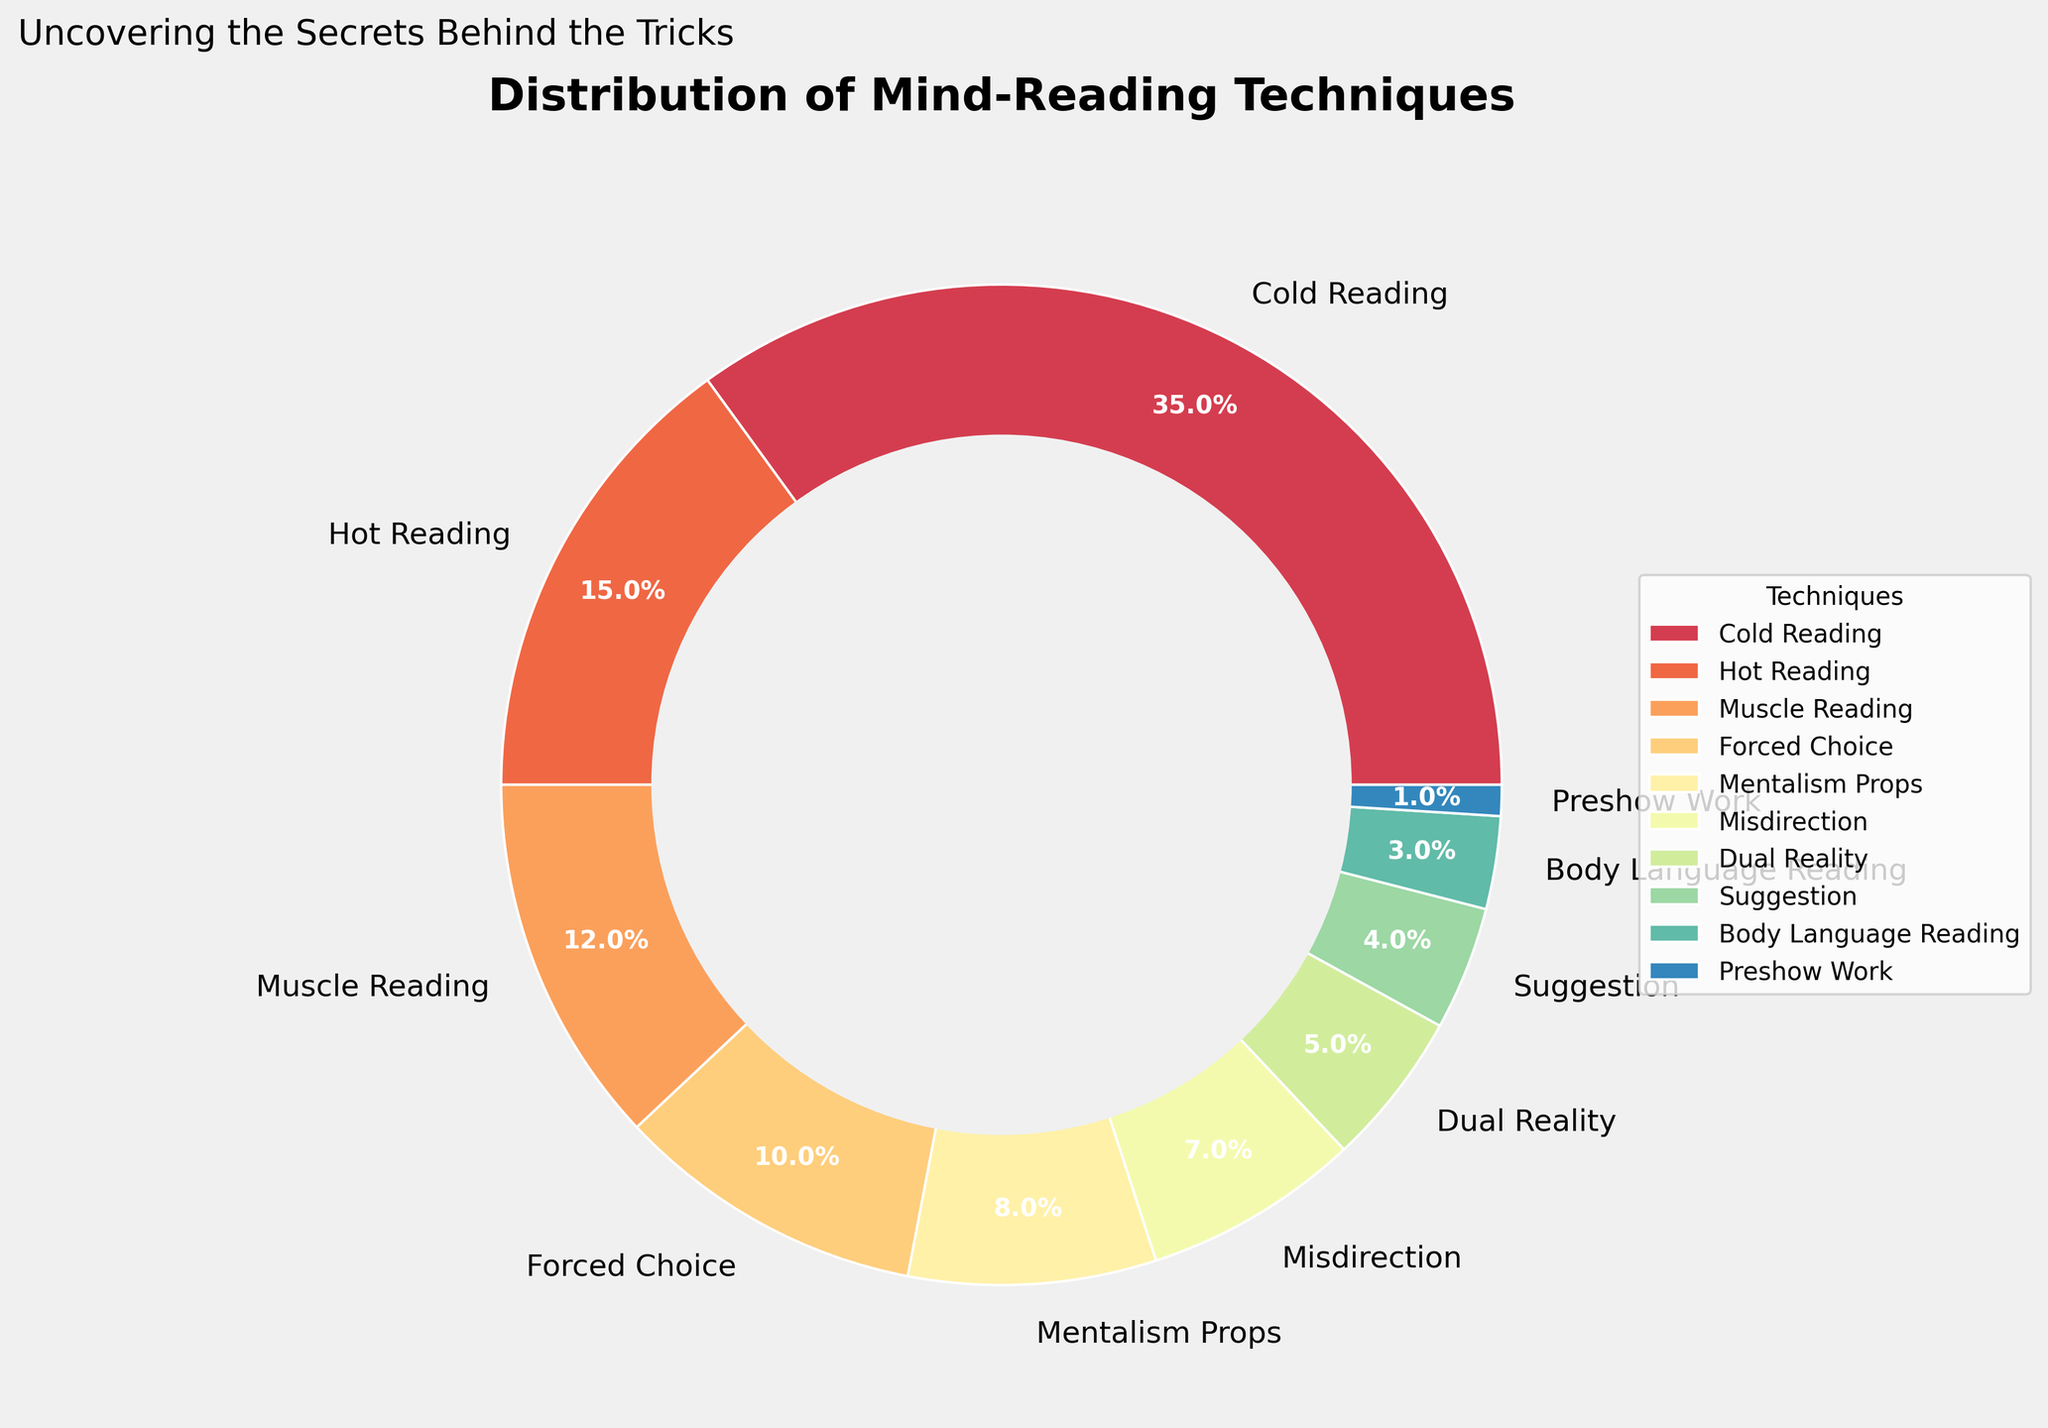What is the technique with the highest percentage in the distribution? Look at the pie chart and identify which technique has the largest slice. The Cold Reading slice is the largest.
Answer: Cold Reading Which technique is used more: Muscle Reading or Misdirection? Compare the slices for Muscle Reading (12%) and Misdirection (7%). Muscle Reading has a greater percentage.
Answer: Muscle Reading What is the combined percentage of Forced Choice and Suggestion techniques? Add the percentages for Forced Choice (10%) and Suggestion (4%). 10% + 4% = 14%.
Answer: 14% Which technique has a smaller percentage: Body Language Reading or Preshow Work? Compare the slices for Body Language Reading (3%) and Preshow Work (1%). Preshow Work has a smaller percentage.
Answer: Preshow Work What is the difference in percentage between Cold Reading and Hot Reading techniques? Subtract the percentage of Hot Reading (15%) from Cold Reading (35%). 35% - 15% = 20%.
Answer: 20% Arrange the techniques with percentages between 5% and 10% in descending order. Locate the percentage values and arrange them: Forced Choice (10%), Mentalism Props (8%), and Misdirection (7%).
Answer: Forced Choice, Mentalism Props, Misdirection Which technique category has almost half the percentage of Muscle Reading? Muscle Reading is 12%, half of that is 6%. Dual Reality is closest with 5%.
Answer: Dual Reality What is the percentage difference between the least used technique and the second least used technique? The least is Preshow Work (1%) and the second least is Body Language Reading (3%). 3% - 1% = 2%.
Answer: 2% Name all the techniques used less than 5% of the time. Identify slices under 5%: Dual Reality (5%), Suggestion (4%), Body Language Reading (3%), and Preshow Work (1%).
Answer: Dual Reality, Suggestion, Body Language Reading, Preshow Work 